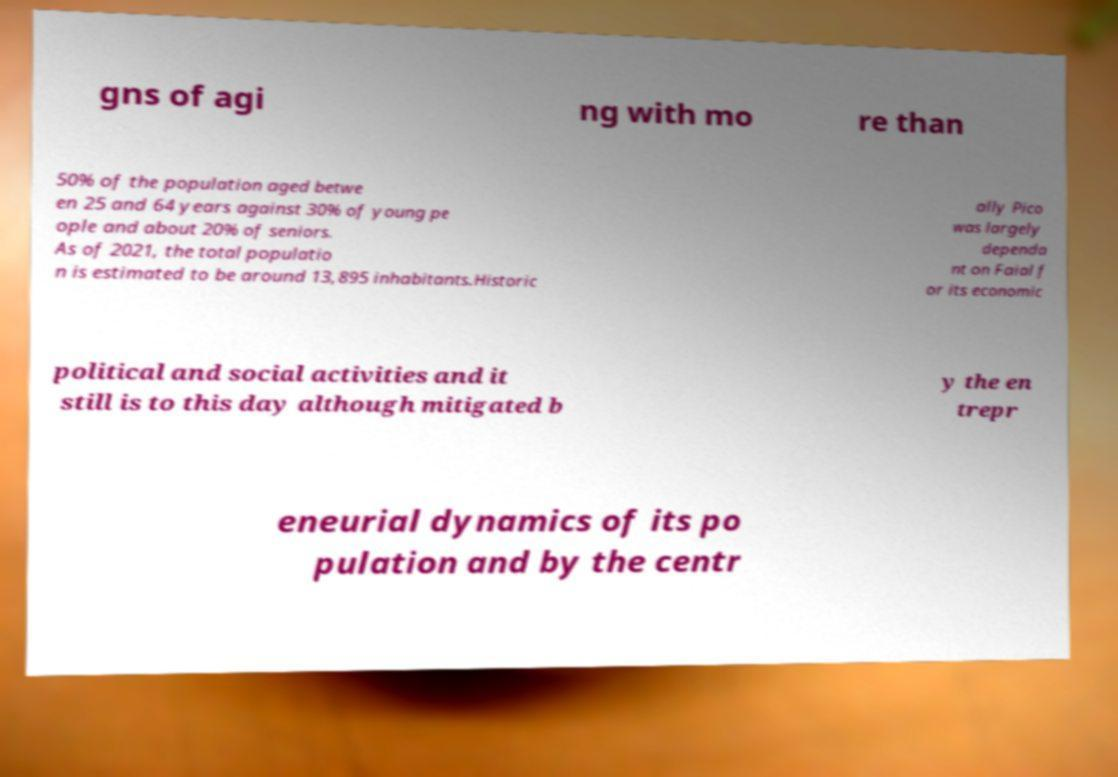For documentation purposes, I need the text within this image transcribed. Could you provide that? gns of agi ng with mo re than 50% of the population aged betwe en 25 and 64 years against 30% of young pe ople and about 20% of seniors. As of 2021, the total populatio n is estimated to be around 13,895 inhabitants.Historic ally Pico was largely dependa nt on Faial f or its economic political and social activities and it still is to this day although mitigated b y the en trepr eneurial dynamics of its po pulation and by the centr 